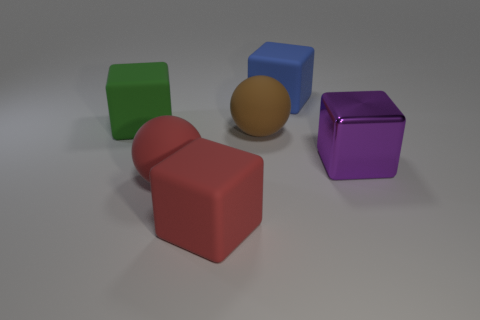Add 1 big purple cubes. How many objects exist? 7 Subtract all rubber cubes. How many cubes are left? 1 Subtract all red balls. How many balls are left? 1 Subtract all balls. How many objects are left? 4 Subtract all purple blocks. Subtract all gray balls. How many blocks are left? 3 Subtract all tiny things. Subtract all large brown things. How many objects are left? 5 Add 2 big metal cubes. How many big metal cubes are left? 3 Add 6 large green matte objects. How many large green matte objects exist? 7 Subtract 0 brown blocks. How many objects are left? 6 